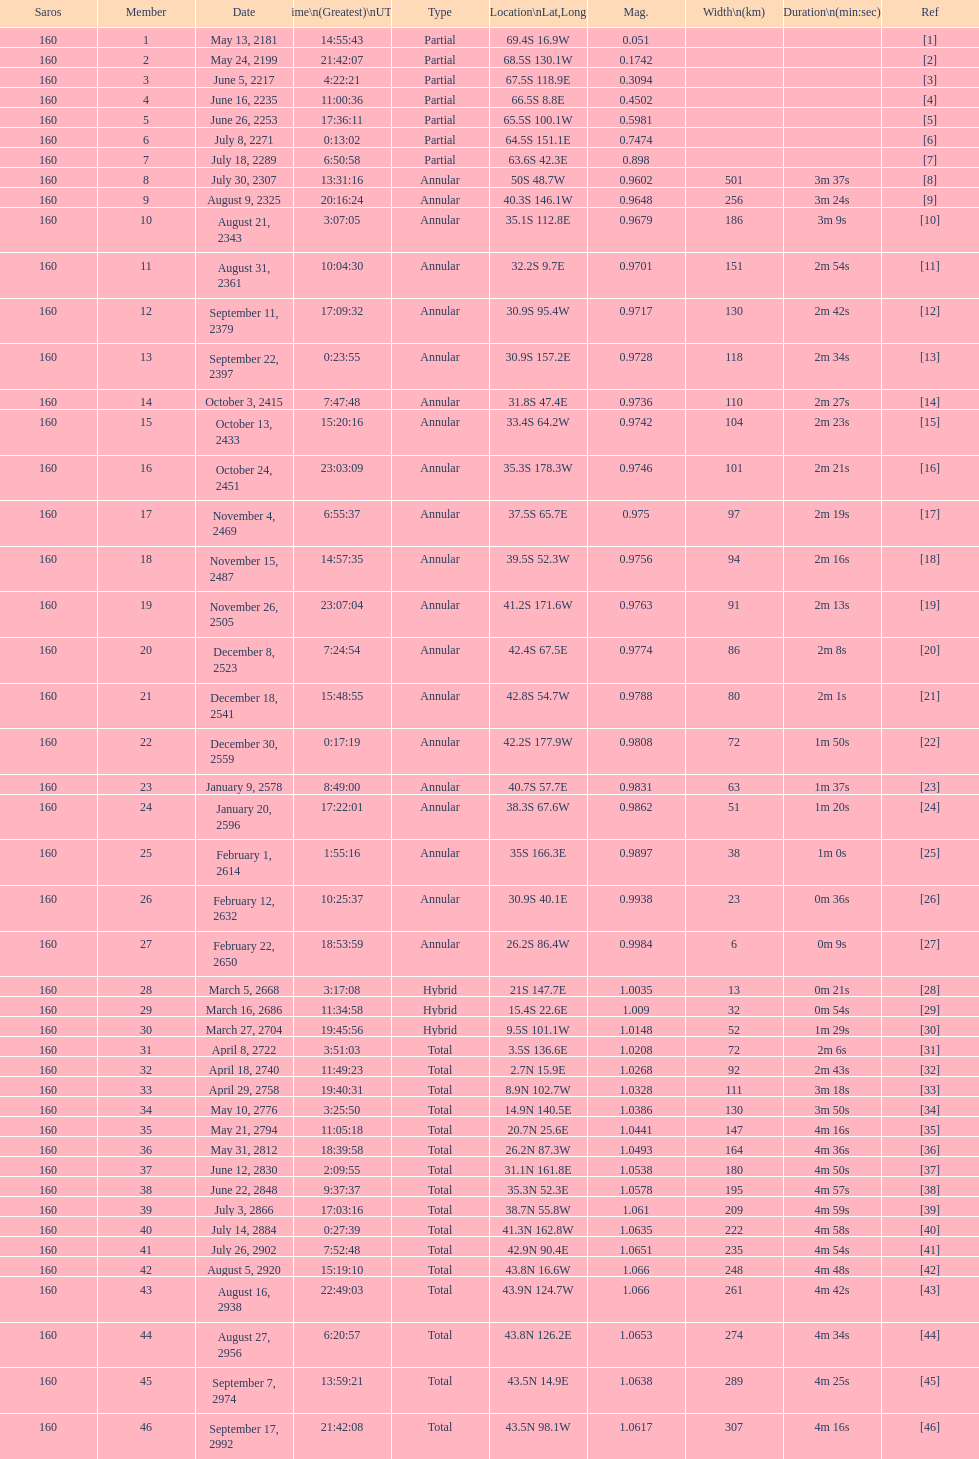Could you parse the entire table as a dict? {'header': ['Saros', 'Member', 'Date', 'Time\\n(Greatest)\\nUTC', 'Type', 'Location\\nLat,Long', 'Mag.', 'Width\\n(km)', 'Duration\\n(min:sec)', 'Ref'], 'rows': [['160', '1', 'May 13, 2181', '14:55:43', 'Partial', '69.4S 16.9W', '0.051', '', '', '[1]'], ['160', '2', 'May 24, 2199', '21:42:07', 'Partial', '68.5S 130.1W', '0.1742', '', '', '[2]'], ['160', '3', 'June 5, 2217', '4:22:21', 'Partial', '67.5S 118.9E', '0.3094', '', '', '[3]'], ['160', '4', 'June 16, 2235', '11:00:36', 'Partial', '66.5S 8.8E', '0.4502', '', '', '[4]'], ['160', '5', 'June 26, 2253', '17:36:11', 'Partial', '65.5S 100.1W', '0.5981', '', '', '[5]'], ['160', '6', 'July 8, 2271', '0:13:02', 'Partial', '64.5S 151.1E', '0.7474', '', '', '[6]'], ['160', '7', 'July 18, 2289', '6:50:58', 'Partial', '63.6S 42.3E', '0.898', '', '', '[7]'], ['160', '8', 'July 30, 2307', '13:31:16', 'Annular', '50S 48.7W', '0.9602', '501', '3m 37s', '[8]'], ['160', '9', 'August 9, 2325', '20:16:24', 'Annular', '40.3S 146.1W', '0.9648', '256', '3m 24s', '[9]'], ['160', '10', 'August 21, 2343', '3:07:05', 'Annular', '35.1S 112.8E', '0.9679', '186', '3m 9s', '[10]'], ['160', '11', 'August 31, 2361', '10:04:30', 'Annular', '32.2S 9.7E', '0.9701', '151', '2m 54s', '[11]'], ['160', '12', 'September 11, 2379', '17:09:32', 'Annular', '30.9S 95.4W', '0.9717', '130', '2m 42s', '[12]'], ['160', '13', 'September 22, 2397', '0:23:55', 'Annular', '30.9S 157.2E', '0.9728', '118', '2m 34s', '[13]'], ['160', '14', 'October 3, 2415', '7:47:48', 'Annular', '31.8S 47.4E', '0.9736', '110', '2m 27s', '[14]'], ['160', '15', 'October 13, 2433', '15:20:16', 'Annular', '33.4S 64.2W', '0.9742', '104', '2m 23s', '[15]'], ['160', '16', 'October 24, 2451', '23:03:09', 'Annular', '35.3S 178.3W', '0.9746', '101', '2m 21s', '[16]'], ['160', '17', 'November 4, 2469', '6:55:37', 'Annular', '37.5S 65.7E', '0.975', '97', '2m 19s', '[17]'], ['160', '18', 'November 15, 2487', '14:57:35', 'Annular', '39.5S 52.3W', '0.9756', '94', '2m 16s', '[18]'], ['160', '19', 'November 26, 2505', '23:07:04', 'Annular', '41.2S 171.6W', '0.9763', '91', '2m 13s', '[19]'], ['160', '20', 'December 8, 2523', '7:24:54', 'Annular', '42.4S 67.5E', '0.9774', '86', '2m 8s', '[20]'], ['160', '21', 'December 18, 2541', '15:48:55', 'Annular', '42.8S 54.7W', '0.9788', '80', '2m 1s', '[21]'], ['160', '22', 'December 30, 2559', '0:17:19', 'Annular', '42.2S 177.9W', '0.9808', '72', '1m 50s', '[22]'], ['160', '23', 'January 9, 2578', '8:49:00', 'Annular', '40.7S 57.7E', '0.9831', '63', '1m 37s', '[23]'], ['160', '24', 'January 20, 2596', '17:22:01', 'Annular', '38.3S 67.6W', '0.9862', '51', '1m 20s', '[24]'], ['160', '25', 'February 1, 2614', '1:55:16', 'Annular', '35S 166.3E', '0.9897', '38', '1m 0s', '[25]'], ['160', '26', 'February 12, 2632', '10:25:37', 'Annular', '30.9S 40.1E', '0.9938', '23', '0m 36s', '[26]'], ['160', '27', 'February 22, 2650', '18:53:59', 'Annular', '26.2S 86.4W', '0.9984', '6', '0m 9s', '[27]'], ['160', '28', 'March 5, 2668', '3:17:08', 'Hybrid', '21S 147.7E', '1.0035', '13', '0m 21s', '[28]'], ['160', '29', 'March 16, 2686', '11:34:58', 'Hybrid', '15.4S 22.6E', '1.009', '32', '0m 54s', '[29]'], ['160', '30', 'March 27, 2704', '19:45:56', 'Hybrid', '9.5S 101.1W', '1.0148', '52', '1m 29s', '[30]'], ['160', '31', 'April 8, 2722', '3:51:03', 'Total', '3.5S 136.6E', '1.0208', '72', '2m 6s', '[31]'], ['160', '32', 'April 18, 2740', '11:49:23', 'Total', '2.7N 15.9E', '1.0268', '92', '2m 43s', '[32]'], ['160', '33', 'April 29, 2758', '19:40:31', 'Total', '8.9N 102.7W', '1.0328', '111', '3m 18s', '[33]'], ['160', '34', 'May 10, 2776', '3:25:50', 'Total', '14.9N 140.5E', '1.0386', '130', '3m 50s', '[34]'], ['160', '35', 'May 21, 2794', '11:05:18', 'Total', '20.7N 25.6E', '1.0441', '147', '4m 16s', '[35]'], ['160', '36', 'May 31, 2812', '18:39:58', 'Total', '26.2N 87.3W', '1.0493', '164', '4m 36s', '[36]'], ['160', '37', 'June 12, 2830', '2:09:55', 'Total', '31.1N 161.8E', '1.0538', '180', '4m 50s', '[37]'], ['160', '38', 'June 22, 2848', '9:37:37', 'Total', '35.3N 52.3E', '1.0578', '195', '4m 57s', '[38]'], ['160', '39', 'July 3, 2866', '17:03:16', 'Total', '38.7N 55.8W', '1.061', '209', '4m 59s', '[39]'], ['160', '40', 'July 14, 2884', '0:27:39', 'Total', '41.3N 162.8W', '1.0635', '222', '4m 58s', '[40]'], ['160', '41', 'July 26, 2902', '7:52:48', 'Total', '42.9N 90.4E', '1.0651', '235', '4m 54s', '[41]'], ['160', '42', 'August 5, 2920', '15:19:10', 'Total', '43.8N 16.6W', '1.066', '248', '4m 48s', '[42]'], ['160', '43', 'August 16, 2938', '22:49:03', 'Total', '43.9N 124.7W', '1.066', '261', '4m 42s', '[43]'], ['160', '44', 'August 27, 2956', '6:20:57', 'Total', '43.8N 126.2E', '1.0653', '274', '4m 34s', '[44]'], ['160', '45', 'September 7, 2974', '13:59:21', 'Total', '43.5N 14.9E', '1.0638', '289', '4m 25s', '[45]'], ['160', '46', 'September 17, 2992', '21:42:08', 'Total', '43.5N 98.1W', '1.0617', '307', '4m 16s', '[46]']]} Identify a member digit with a latitude higher than 60 s. 1. 